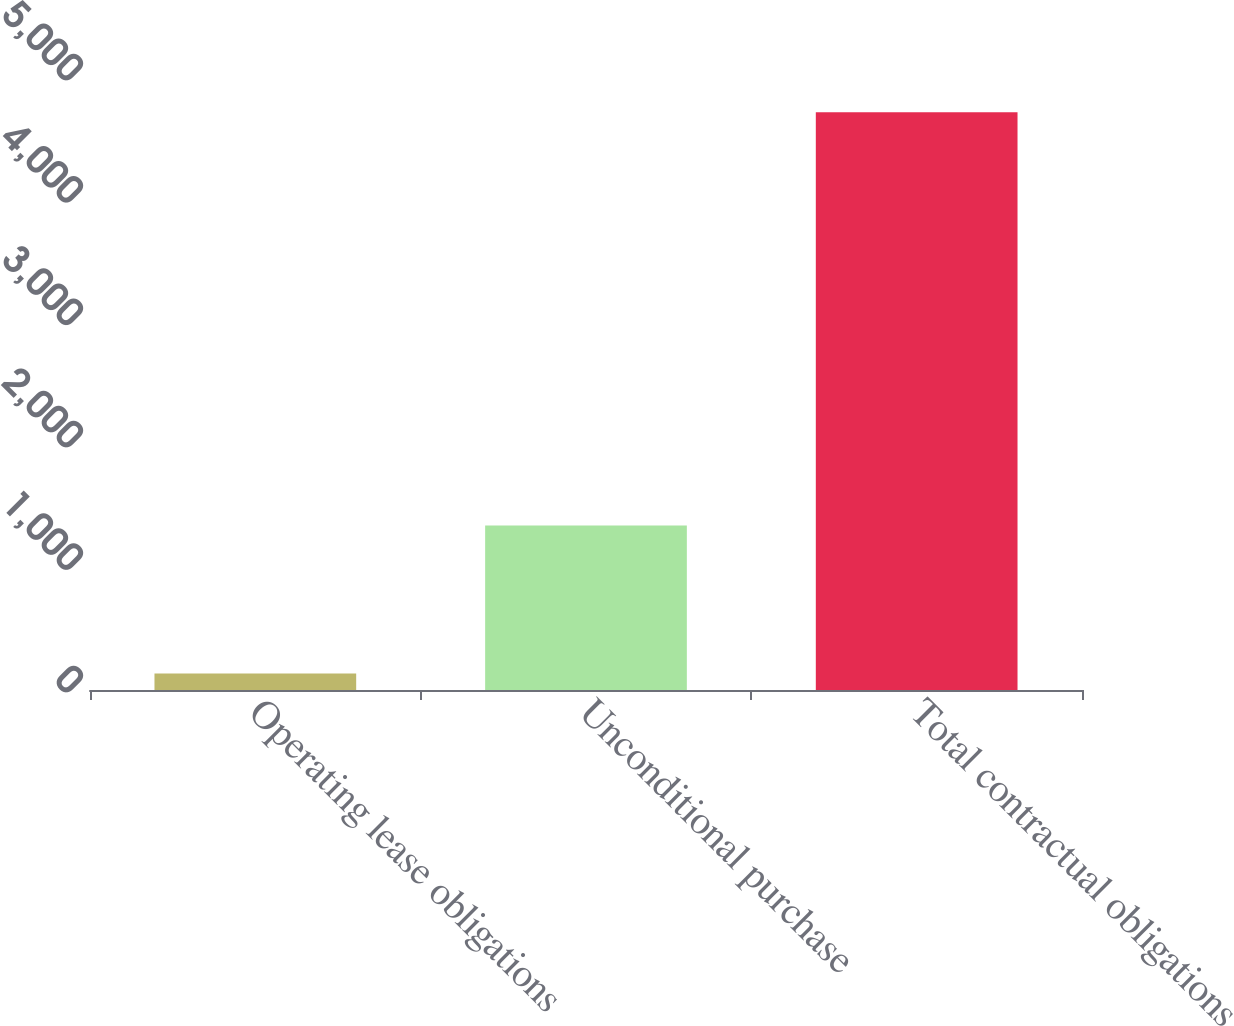Convert chart. <chart><loc_0><loc_0><loc_500><loc_500><bar_chart><fcel>Operating lease obligations<fcel>Unconditional purchase<fcel>Total contractual obligations<nl><fcel>135.7<fcel>1343.4<fcel>4719.9<nl></chart> 